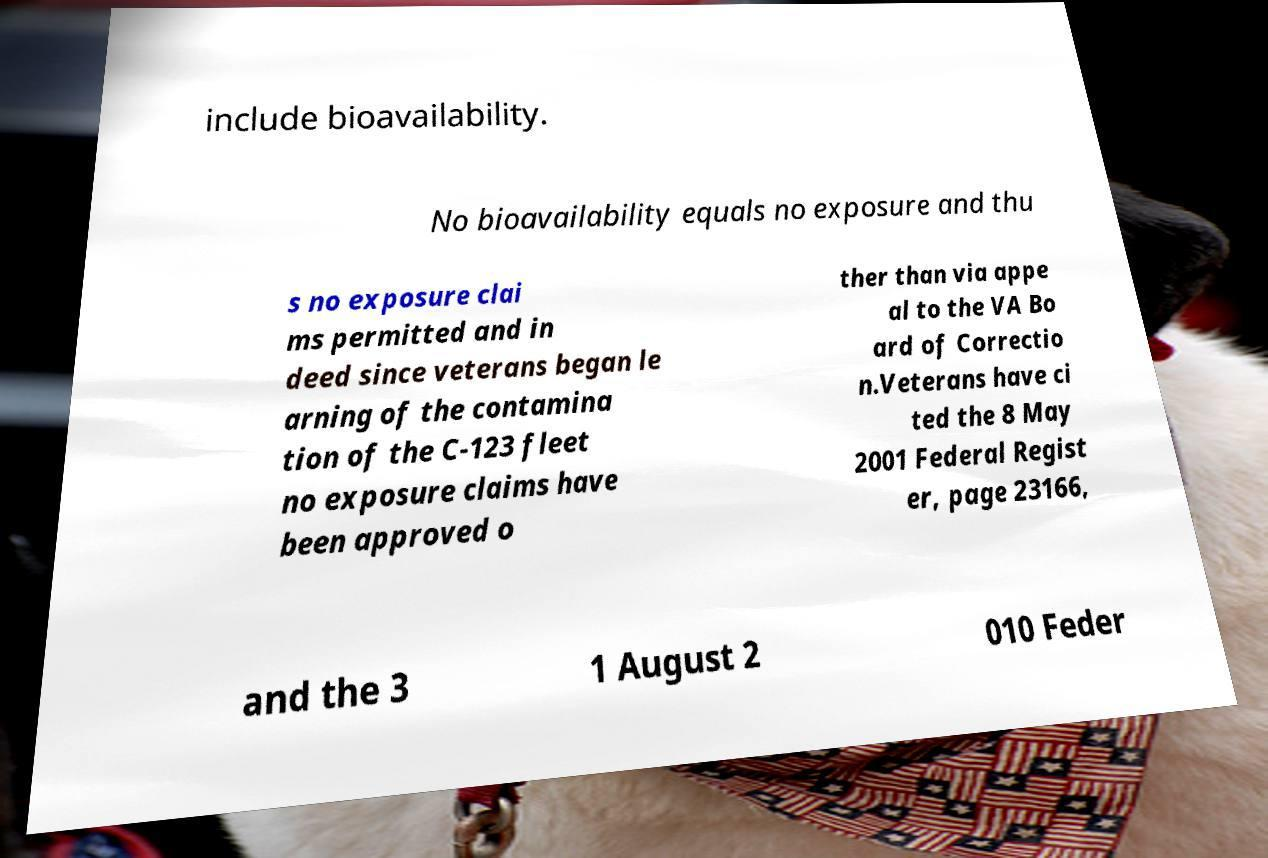Could you extract and type out the text from this image? include bioavailability. No bioavailability equals no exposure and thu s no exposure clai ms permitted and in deed since veterans began le arning of the contamina tion of the C-123 fleet no exposure claims have been approved o ther than via appe al to the VA Bo ard of Correctio n.Veterans have ci ted the 8 May 2001 Federal Regist er, page 23166, and the 3 1 August 2 010 Feder 